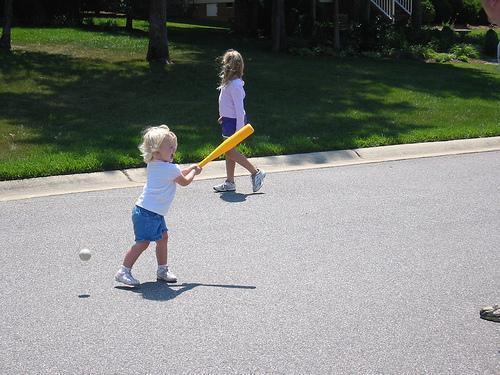How many bats are there?
Give a very brief answer. 1. How many people are depicted?
Give a very brief answer. 2. How many people are in this photo?
Give a very brief answer. 2. How many people are in the picture?
Give a very brief answer. 2. How many palm trees are to the right of the orange bus?
Give a very brief answer. 0. 